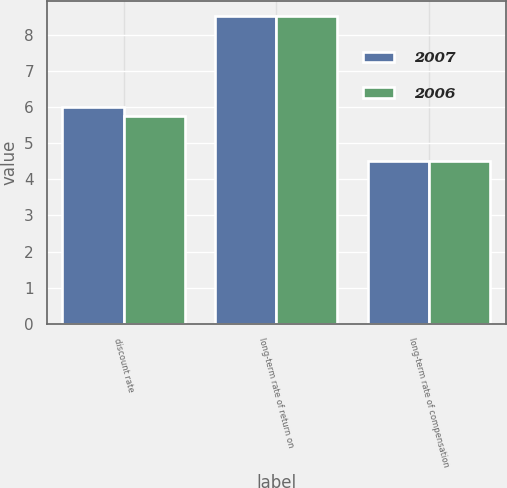<chart> <loc_0><loc_0><loc_500><loc_500><stacked_bar_chart><ecel><fcel>discount rate<fcel>long-term rate of return on<fcel>long-term rate of compensation<nl><fcel>2007<fcel>6<fcel>8.5<fcel>4.5<nl><fcel>2006<fcel>5.75<fcel>8.5<fcel>4.5<nl></chart> 